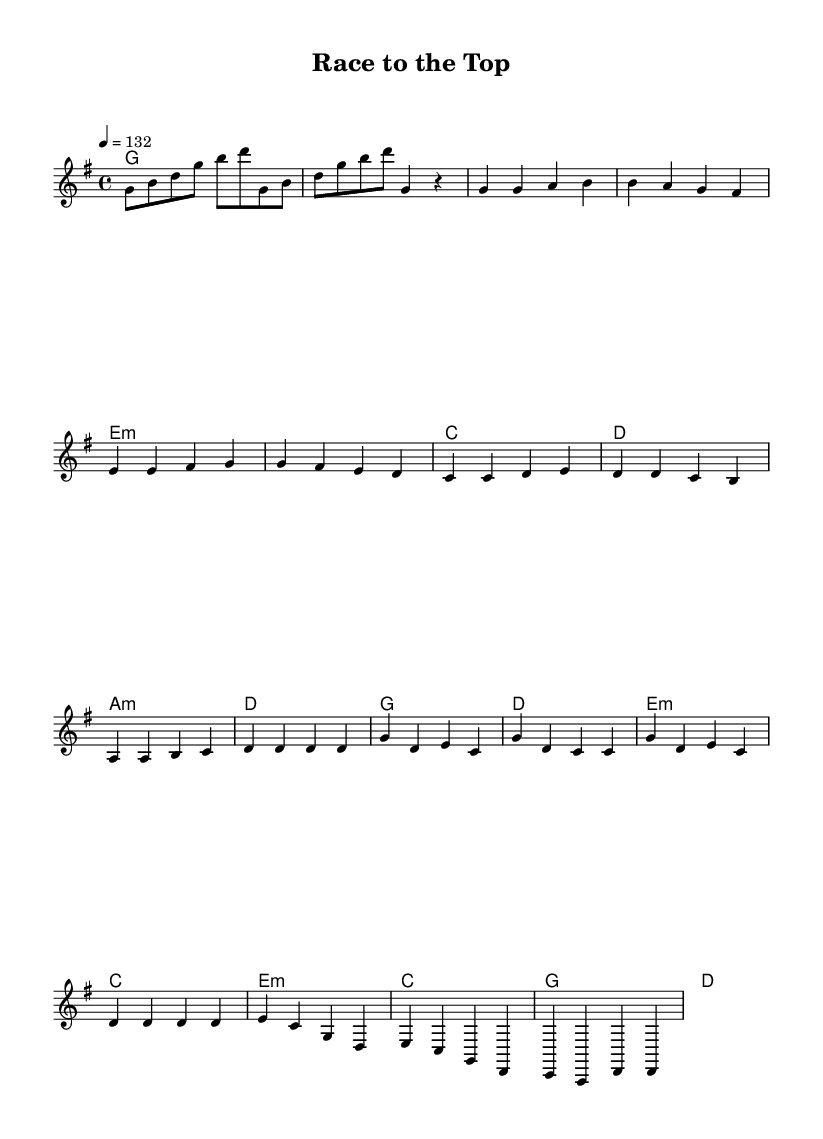What is the key signature of this music? The key signature shown is G major, which contains one sharp (F#). This can be identified by looking at the key signature placed at the beginning of the staff.
Answer: G major What is the time signature of this music? The time signature displayed is 4/4, which indicates four beats per measure and a quarter note gets one beat. This is located at the beginning of the sheet music.
Answer: 4/4 What is the tempo marking for this song? The tempo marking at the top states "4 = 132," meaning the quarter note is to be played at a speed of 132 beats per minute. This tempo indication sets the pace for the song.
Answer: 132 How many measures are in the chorus? The chorus section consists of four measures, which can be counted visually by identifying the line breaks in that specific section of the music.
Answer: 4 What is the primary chord used in the verse? The primary chord used in the verse is G major. By examining the harmony section corresponding to the verse, you will find the G major chord repeated throughout.
Answer: G What is the emotional theme of this song based on its title and sections? The title "Race to the Top" suggests themes of perseverance and determination, which are revealed in the upbeat nature of the melody and lyrics through the chorus and overall structure. The structure promotes a sense of overcoming obstacles.
Answer: Perseverance 